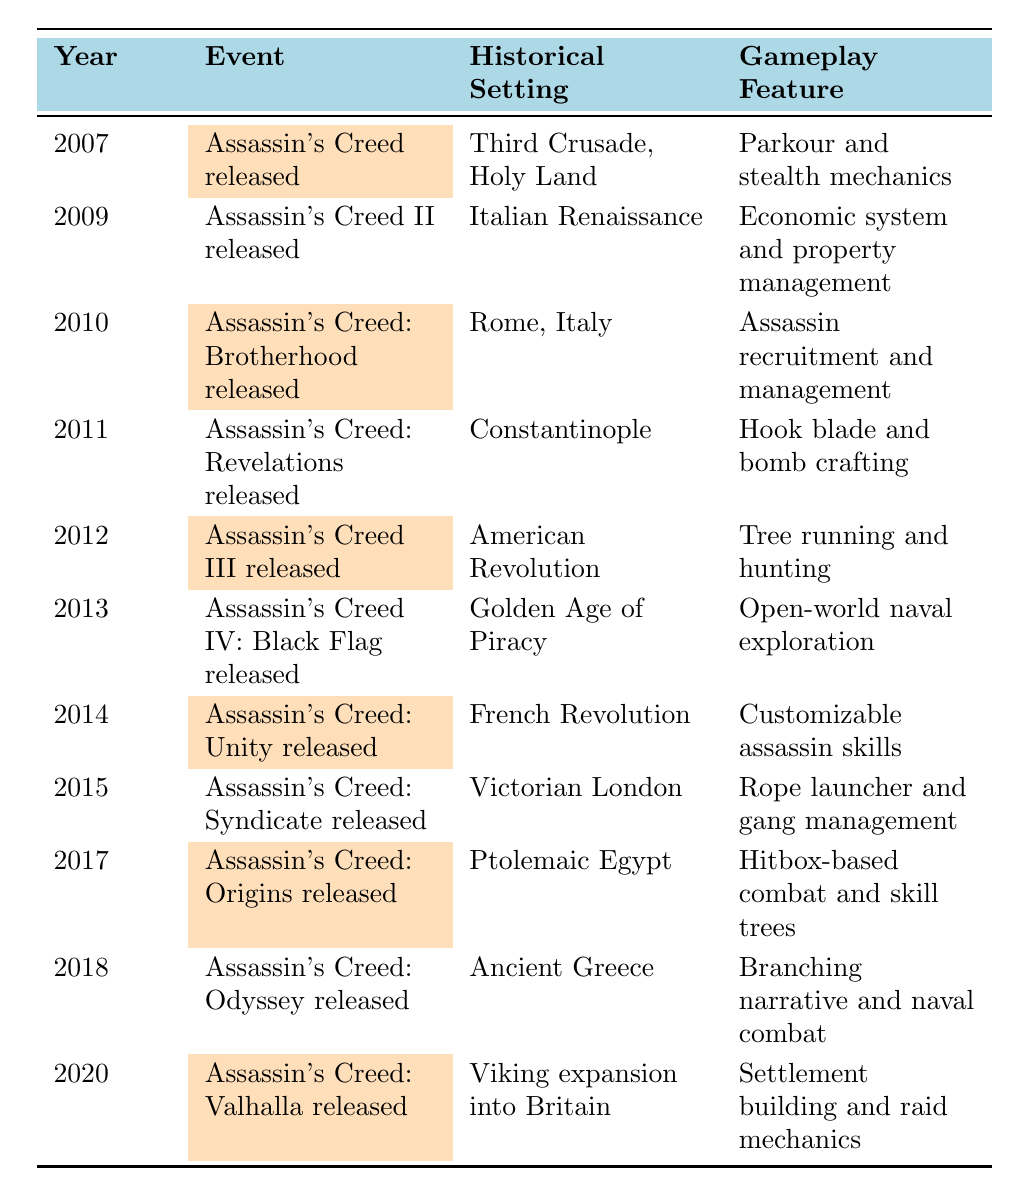What year was "Assassin's Creed: Brotherhood" released? According to the table, "Assassin's Creed: Brotherhood" was released in the year 2010. This information is explicitly stated in the corresponding row of the timeline.
Answer: 2010 What is the historical setting of "Assassin's Creed III"? The table indicates that "Assassin's Creed III" is set during the American Revolution. This detail is found in the row that mentions this specific game.
Answer: American Revolution Did any of the games introduced before 2015 feature naval gameplay? Yes, both "Assassin's Creed III" and "Assassin's Creed IV: Black Flag" feature naval gameplay, as indicated in their respective rows. "Assassin's Creed III" introduced naval combat, while "Assassin's Creed IV: Black Flag" expanded on that with open-world naval exploration.
Answer: Yes What is the unique gameplay feature introduced in "Assassin's Creed: Syndicate"? The unique gameplay feature of "Assassin's Creed: Syndicate" is the rope launcher and gang management. This information is captured in the row detailing this specific title.
Answer: Rope launcher and gang management Which game set in Ancient Greece was released after 2016? "Assassin's Creed: Odyssey," which is set in Ancient Greece, was released in 2018, according to the timeline. This indicates it was the game released after 2016.
Answer: Assassin's Creed: Odyssey How many games were released in the 2010s decade according to the table? The table shows that there are seven games released between 2010 and 2019, specifically in 2010, 2011, 2012, 2013, 2014, 2015, 2017, and 2018. By counting each row in that time frame, we get a total of seven games.
Answer: 7 Which historical setting had the earliest representation in this franchise? The earliest historical setting represented in the franchise is the Third Crusade, Holy Land, that corresponds to the release of "Assassin's Creed" in 2007, as per the first row in the table.
Answer: Third Crusade, Holy Land How does the gameplay feature differ between "Assassin's Creed: Origins" and "Assassin's Creed: Valhalla"? "Assassin's Creed: Origins" features hitbox-based combat and skill trees, while "Assassin's Creed: Valhalla" features settlement building and raid mechanics. This is clear from the rows corresponding to each game.
Answer: Different gameplay features Was "Assassin's Creed: Unity" the first game to introduce cooperative multiplayer? Yes, the table notes that "Assassin's Creed: Unity," released in 2014, introduced cooperative multiplayer, making it the first game in the franchise to do so.
Answer: Yes What gameplay feature was added in "Assassin's Creed II" that was not present in the original game? "Assassin's Creed II" introduced an economic system and property management, which were not present in the original "Assassin's Creed," as shown in the comparison of the two rows in the timeline.
Answer: Economic system and property management 